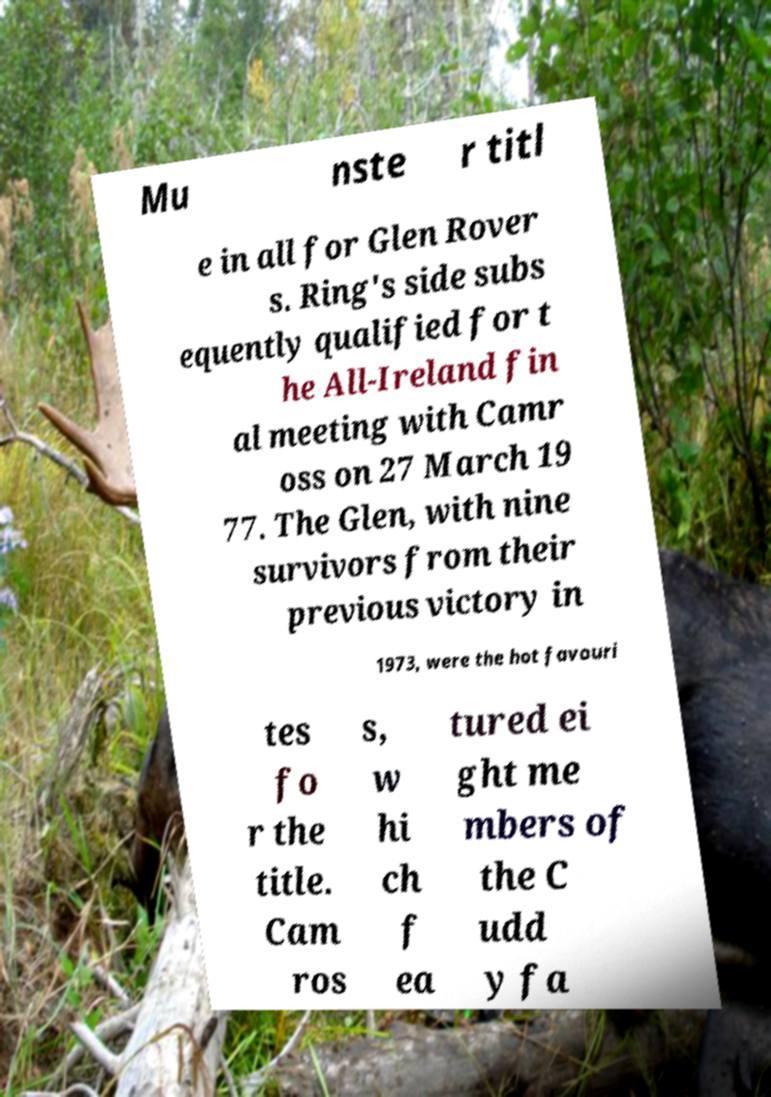I need the written content from this picture converted into text. Can you do that? Mu nste r titl e in all for Glen Rover s. Ring's side subs equently qualified for t he All-Ireland fin al meeting with Camr oss on 27 March 19 77. The Glen, with nine survivors from their previous victory in 1973, were the hot favouri tes fo r the title. Cam ros s, w hi ch f ea tured ei ght me mbers of the C udd y fa 